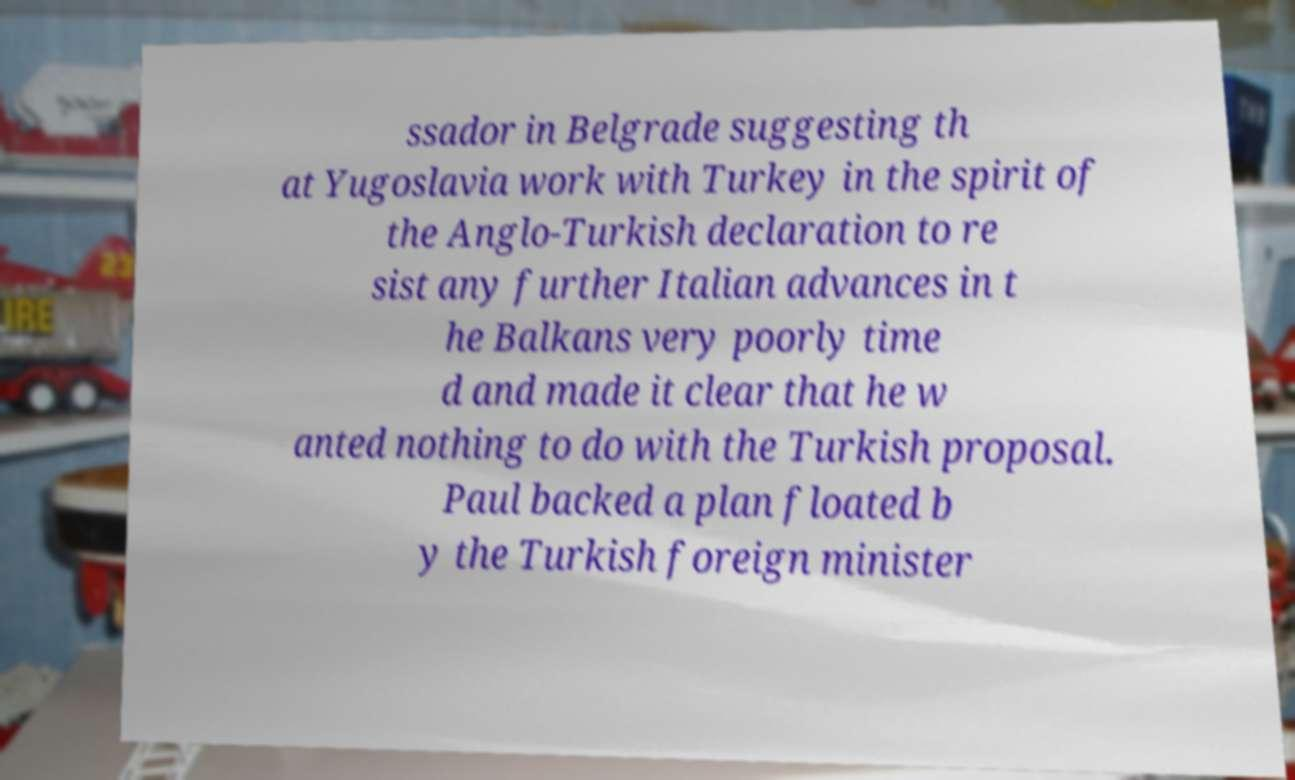There's text embedded in this image that I need extracted. Can you transcribe it verbatim? ssador in Belgrade suggesting th at Yugoslavia work with Turkey in the spirit of the Anglo-Turkish declaration to re sist any further Italian advances in t he Balkans very poorly time d and made it clear that he w anted nothing to do with the Turkish proposal. Paul backed a plan floated b y the Turkish foreign minister 